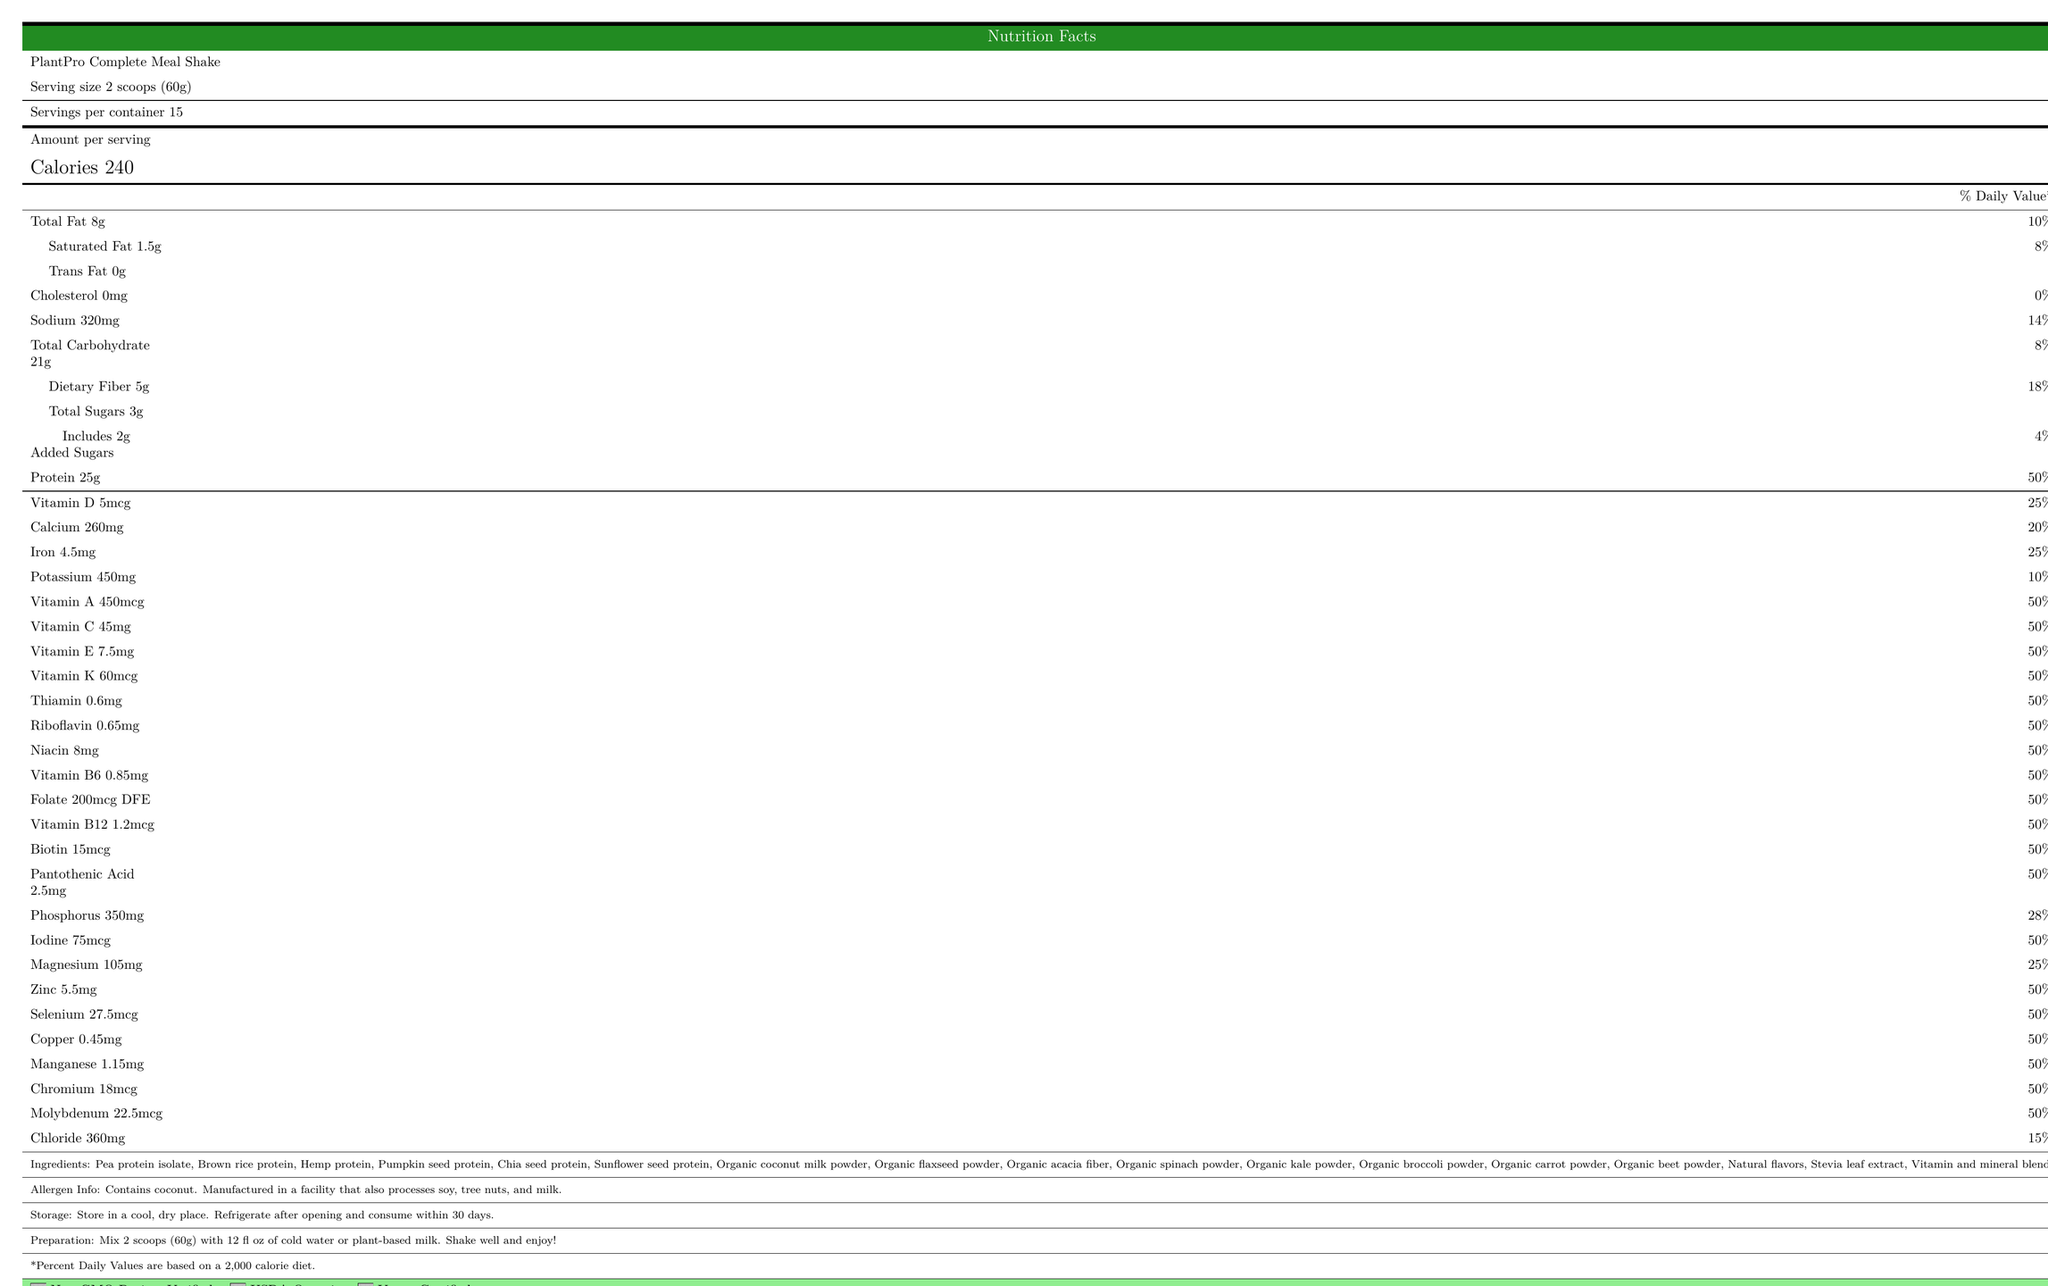1. What is the serving size of the PlantPro Complete Meal Shake? The document states that the serving size is 2 scoops (60g) clearly in the "Serving size" section.
Answer: 2 scoops (60g) 2. How many calories are there per serving? The document specifies that there are 240 calories per serving under the "Amount per serving" section.
Answer: 240 3. What is the total amount of protein per serving? The "Protein" section of the document mentions that there are 25 grams of protein per serving.
Answer: 25g 4. How much dietary fiber does each serving contain? The "Dietary Fiber" section indicates that each serving contains 5 grams of dietary fiber.
Answer: 5g 5. What are the ingredients listed in the PlantPro Complete Meal Shake? The document provides a comprehensive list of ingredients used in the shake under the "Ingredients" section.
Answer: Pea protein isolate, Brown rice protein, Hemp protein, Pumpkin seed protein, Chia seed protein, Sunflower seed protein, Organic coconut milk powder, Organic flaxseed powder, Organic acacia fiber, Organic spinach powder, Organic kale powder, Organic broccoli powder, Organic carrot powder, Organic beet powder, Natural flavors, Stevia leaf extract, Vitamin and mineral blend 6. How many servings are there per container? It's clearly mentioned under the "Servings per container" section.
Answer: 15 7. What percent of the daily value for sodium does one serving provide? The document lists the daily value percentage for sodium as 14% in the "Sodium" section.
Answer: 14% 8. How should this meal replacement shake be stored after opening? The "Storage" section of the document provides these instructions.
Answer: Refrigerate after opening and consume within 30 days 9. Which of the following vitamins are present in 50% of the daily value? A. Vitamin D B. Vitamin C C. Vitamin B6 D. Vitamin A Both Vitamin C and Vitamin A are present at 50% of the daily value as listed in the "Vitamin C" and "Vitamin A" sections.
Answer: B and D 10. Which of these nutrients is found in the highest daily value percentage in one serving? A. Calcium B. Iron C. Protein D. Vitamin D The document states that protein has the highest daily value percentage at 50%, which is more than Calcium (20%), Iron (25%), or Vitamin D (25%).
Answer: C 11. Is there any cholesterol in the PlantPro Complete Meal Shake? The document lists cholesterol as 0mg.
Answer: No 12. Does the packaging mention any allergens? The document states that the product contains coconut and is manufactured in a facility that also processes soy, tree nuts, and milk.
Answer: Yes 13. Provide a summary of the nutritional content and additional information on the PlantPro Complete Meal Shake. This encapsulates the key nutritional information, ingredient details, and additional certifications and instructions provided in the document.
Answer: The PlantPro Complete Meal Shake provides 240 calories per serving, with 25 grams of protein and 8 grams of total fat. It includes various vitamins and minerals with significant daily value percentages. Furthermore, it contains plant protein sources and is certified Non-GMO, USDA Organic, and Vegan Certified. It must be refrigerated after opening and consumed within 30 days. 14. What is the total carbohydrate content per serving? The document lists that each serving has 21 grams of total carbohydrates.
Answer: 21g 15. Are there any sugars added to the shake? The document includes added sugars information, which is 2 grams per serving.
Answer: Yes 16. How much potassium does one serving contain? Potassium content per serving is listed in the document as 450mg.
Answer: 450mg 17. Can the plant-based meal shake be mixed with regular cow milk based on the preparation instructions? The preparation instructions specifically mention cold water or plant-based milk. There is no mention of mixing it with regular cow milk.
Answer: Not enough information 18. Which certifications does the PlantPro Complete Meal Shake have? The certifications are listed at the bottom of the document under "certifications".
Answer: Non-GMO Project Verified, USDA Organic, Vegan Certified 